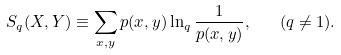Convert formula to latex. <formula><loc_0><loc_0><loc_500><loc_500>S _ { q } ( X , Y ) \equiv \sum _ { x , y } p ( x , y ) \ln _ { q } \frac { 1 } { p ( x , y ) } , \quad ( q \neq 1 ) .</formula> 